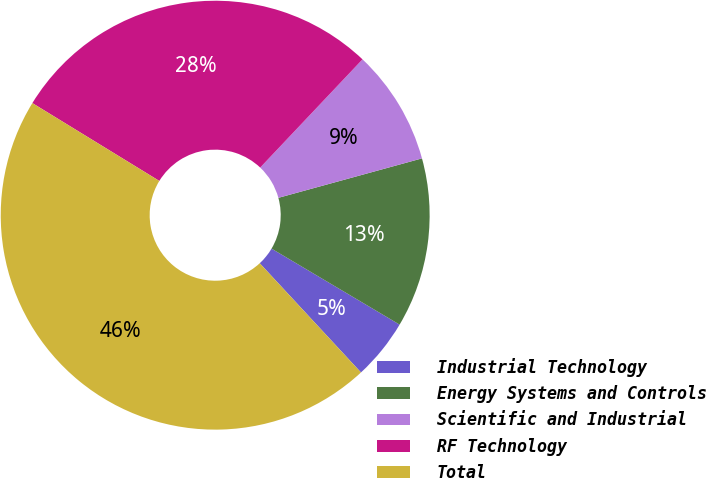Convert chart. <chart><loc_0><loc_0><loc_500><loc_500><pie_chart><fcel>Industrial Technology<fcel>Energy Systems and Controls<fcel>Scientific and Industrial<fcel>RF Technology<fcel>Total<nl><fcel>4.58%<fcel>12.79%<fcel>8.68%<fcel>28.3%<fcel>45.65%<nl></chart> 